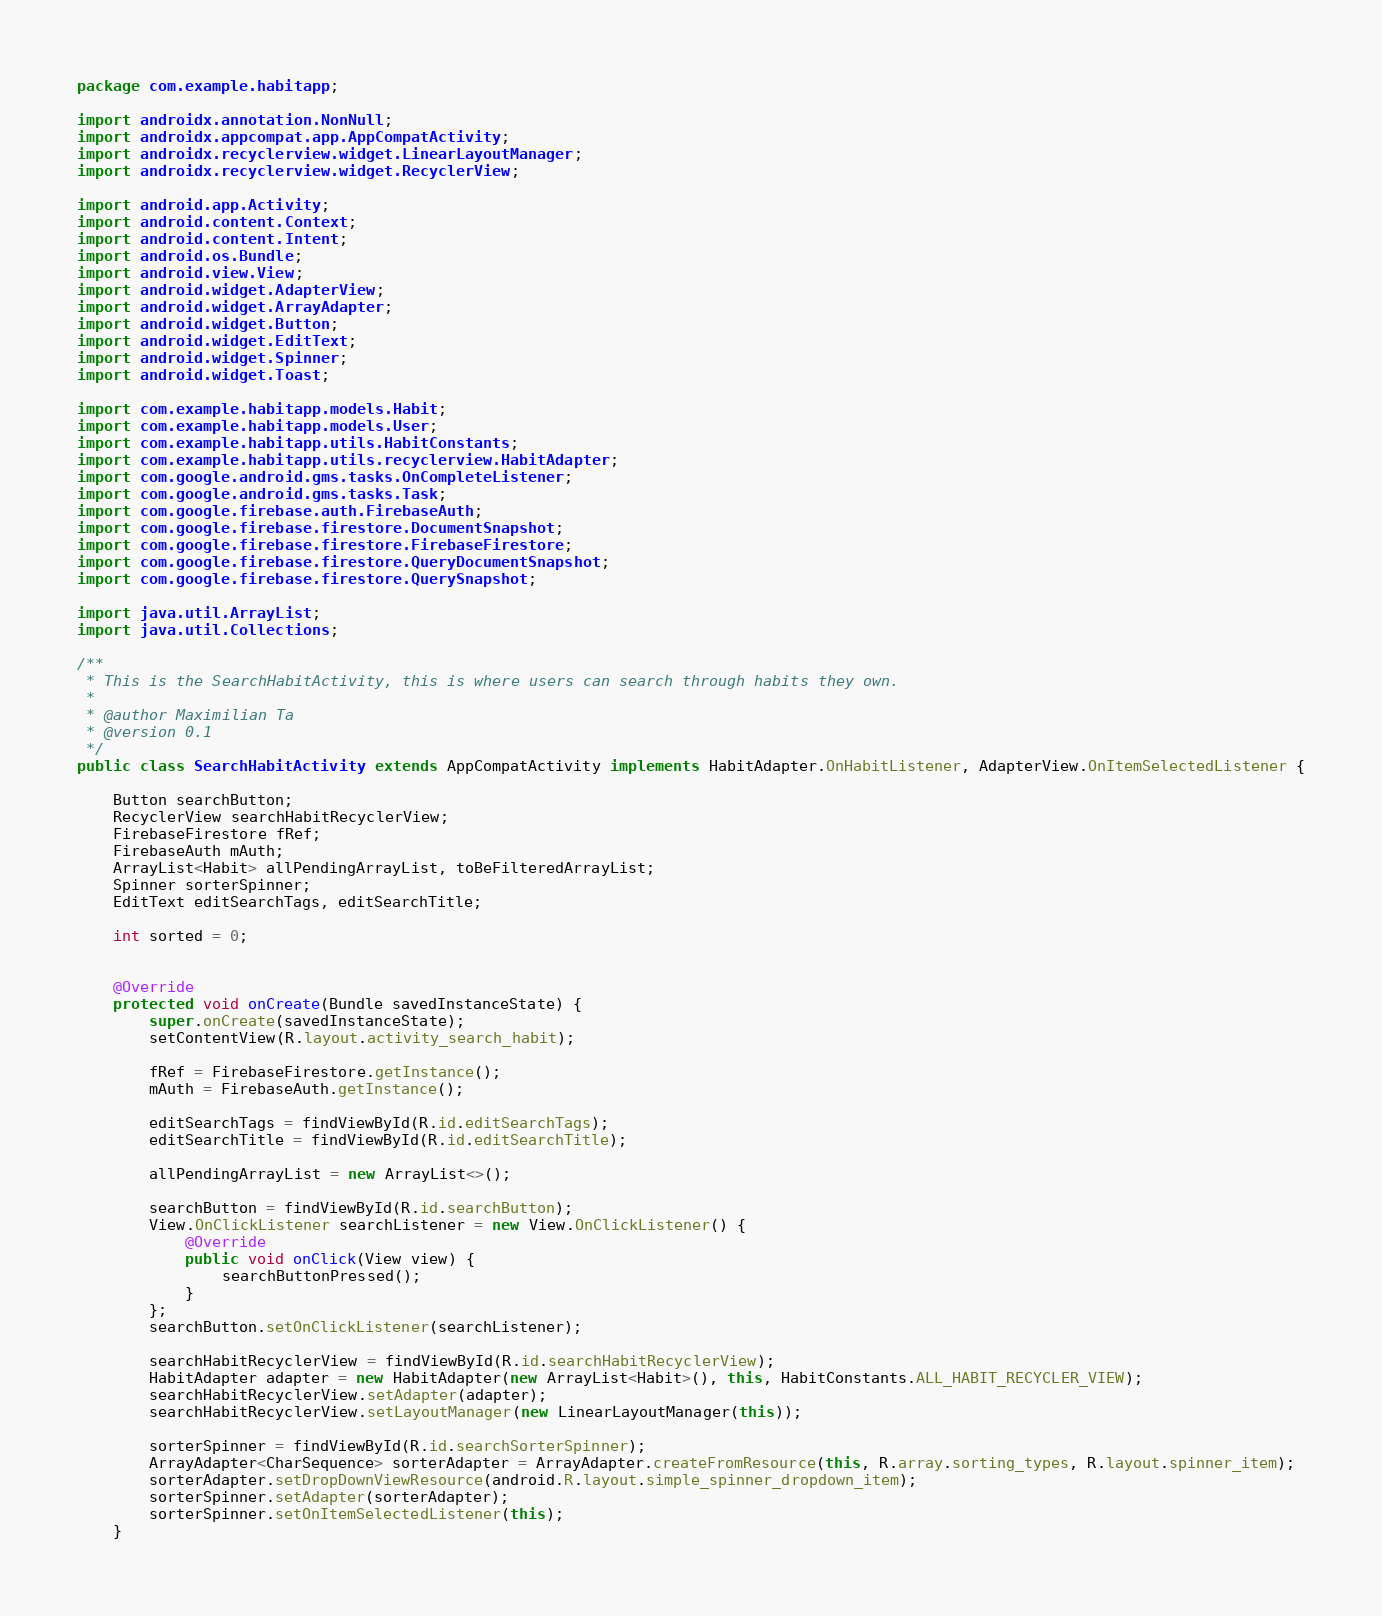Convert code to text. <code><loc_0><loc_0><loc_500><loc_500><_Java_>package com.example.habitapp;

import androidx.annotation.NonNull;
import androidx.appcompat.app.AppCompatActivity;
import androidx.recyclerview.widget.LinearLayoutManager;
import androidx.recyclerview.widget.RecyclerView;

import android.app.Activity;
import android.content.Context;
import android.content.Intent;
import android.os.Bundle;
import android.view.View;
import android.widget.AdapterView;
import android.widget.ArrayAdapter;
import android.widget.Button;
import android.widget.EditText;
import android.widget.Spinner;
import android.widget.Toast;

import com.example.habitapp.models.Habit;
import com.example.habitapp.models.User;
import com.example.habitapp.utils.HabitConstants;
import com.example.habitapp.utils.recyclerview.HabitAdapter;
import com.google.android.gms.tasks.OnCompleteListener;
import com.google.android.gms.tasks.Task;
import com.google.firebase.auth.FirebaseAuth;
import com.google.firebase.firestore.DocumentSnapshot;
import com.google.firebase.firestore.FirebaseFirestore;
import com.google.firebase.firestore.QueryDocumentSnapshot;
import com.google.firebase.firestore.QuerySnapshot;

import java.util.ArrayList;
import java.util.Collections;

/**
 * This is the SearchHabitActivity, this is where users can search through habits they own.
 *
 * @author Maximilian Ta
 * @version 0.1
 */
public class SearchHabitActivity extends AppCompatActivity implements HabitAdapter.OnHabitListener, AdapterView.OnItemSelectedListener {

    Button searchButton;
    RecyclerView searchHabitRecyclerView;
    FirebaseFirestore fRef;
    FirebaseAuth mAuth;
    ArrayList<Habit> allPendingArrayList, toBeFilteredArrayList;
    Spinner sorterSpinner;
    EditText editSearchTags, editSearchTitle;

    int sorted = 0;


    @Override
    protected void onCreate(Bundle savedInstanceState) {
        super.onCreate(savedInstanceState);
        setContentView(R.layout.activity_search_habit);

        fRef = FirebaseFirestore.getInstance();
        mAuth = FirebaseAuth.getInstance();

        editSearchTags = findViewById(R.id.editSearchTags);
        editSearchTitle = findViewById(R.id.editSearchTitle);

        allPendingArrayList = new ArrayList<>();

        searchButton = findViewById(R.id.searchButton);
        View.OnClickListener searchListener = new View.OnClickListener() {
            @Override
            public void onClick(View view) {
                searchButtonPressed();
            }
        };
        searchButton.setOnClickListener(searchListener);

        searchHabitRecyclerView = findViewById(R.id.searchHabitRecyclerView);
        HabitAdapter adapter = new HabitAdapter(new ArrayList<Habit>(), this, HabitConstants.ALL_HABIT_RECYCLER_VIEW);
        searchHabitRecyclerView.setAdapter(adapter);
        searchHabitRecyclerView.setLayoutManager(new LinearLayoutManager(this));

        sorterSpinner = findViewById(R.id.searchSorterSpinner);
        ArrayAdapter<CharSequence> sorterAdapter = ArrayAdapter.createFromResource(this, R.array.sorting_types, R.layout.spinner_item);
        sorterAdapter.setDropDownViewResource(android.R.layout.simple_spinner_dropdown_item);
        sorterSpinner.setAdapter(sorterAdapter);
        sorterSpinner.setOnItemSelectedListener(this);
    }
</code> 